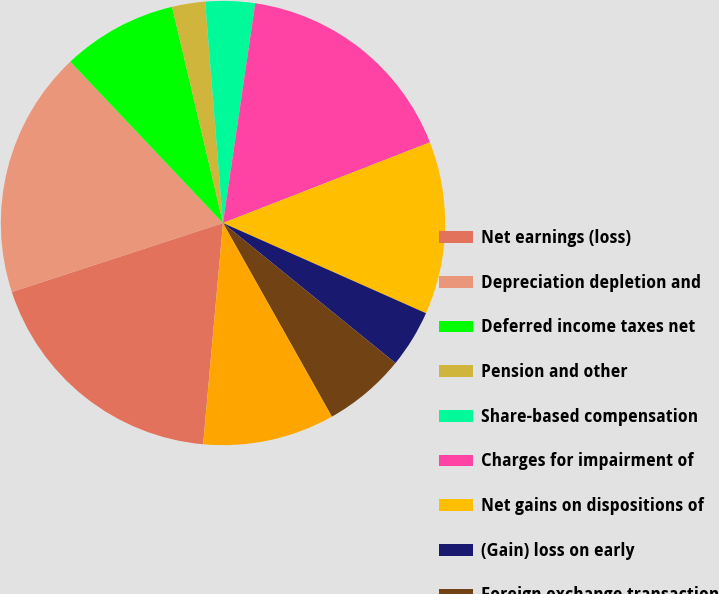Convert chart. <chart><loc_0><loc_0><loc_500><loc_500><pie_chart><fcel>Net earnings (loss)<fcel>Depreciation depletion and<fcel>Deferred income taxes net<fcel>Pension and other<fcel>Share-based compensation<fcel>Charges for impairment of<fcel>Net gains on dispositions of<fcel>(Gain) loss on early<fcel>Foreign exchange transaction<fcel>Receivables less allowances<nl><fcel>18.55%<fcel>17.96%<fcel>8.38%<fcel>2.4%<fcel>3.6%<fcel>16.76%<fcel>12.57%<fcel>4.2%<fcel>5.99%<fcel>9.58%<nl></chart> 